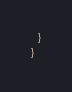<code> <loc_0><loc_0><loc_500><loc_500><_Scala_>  }
}




</code> 